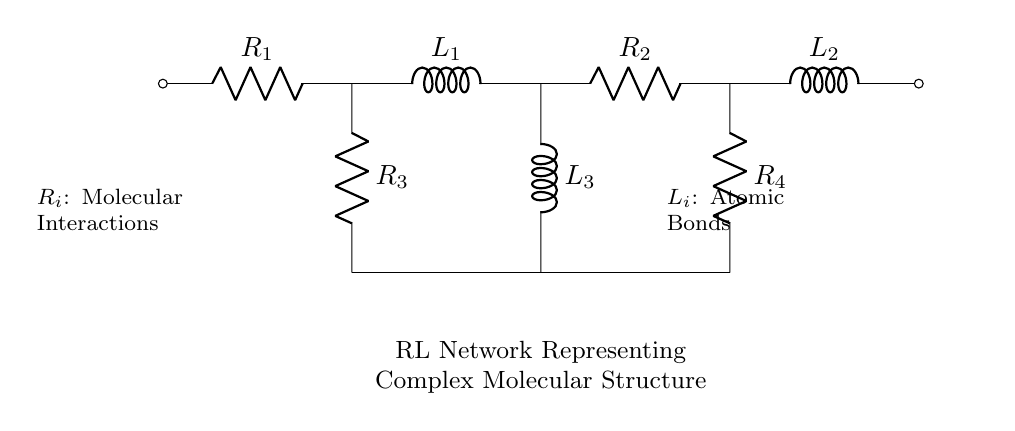What are the components in this circuit? The circuit contains resistors and inductors, specifically labeled as R1, R2, R3, R4, L1, L2, and L3.
Answer: resistors and inductors How many resistors are present in the circuit? There are four resistors labeled R1, R2, R3, and R4 in the diagram.
Answer: four What does the notation R_i represent in this circuit? R_i represents molecular interactions according to the annotations in the diagram, indicating a relationship with the resistors in the circuit.
Answer: Molecular interactions Which elements represent atomic bonds in the circuit? The inductors, labeled as L1, L2, and L3 in the circuit, represent atomic bonds, as indicated by the description in the diagram.
Answer: Atomic bonds What is the configuration of R3, L3, and R4? R3, L3, and R4 are all connected in parallel, shown by their direct connections along the lower path of the circuit.
Answer: Parallel Why is the RL network used to represent complex molecular structures? An RL network captures both resistive (R) and inductive (L) interactions, which can be analogous to the complexities of molecular structures and their interactions in computational chemistry simulations.
Answer: Complex molecular structures How many inductors are there in the circuit? The circuit has three inductors labeled L1, L2, and L3.
Answer: three 